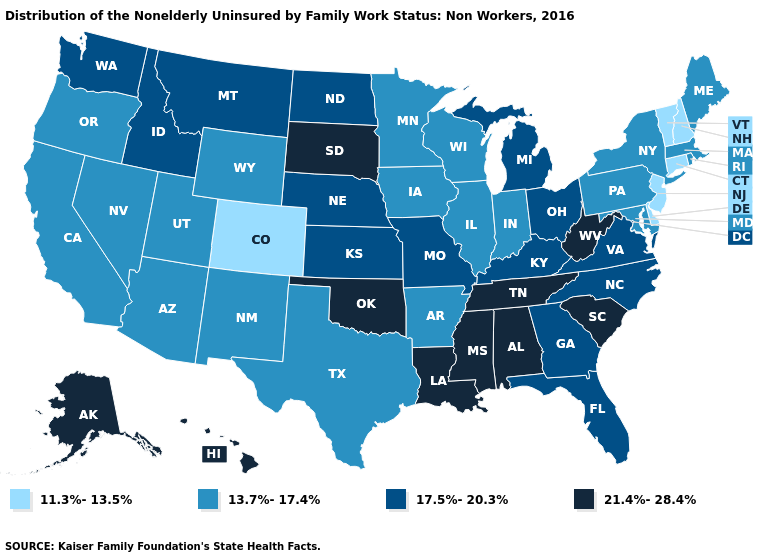What is the value of Maine?
Short answer required. 13.7%-17.4%. Name the states that have a value in the range 21.4%-28.4%?
Be succinct. Alabama, Alaska, Hawaii, Louisiana, Mississippi, Oklahoma, South Carolina, South Dakota, Tennessee, West Virginia. Name the states that have a value in the range 21.4%-28.4%?
Give a very brief answer. Alabama, Alaska, Hawaii, Louisiana, Mississippi, Oklahoma, South Carolina, South Dakota, Tennessee, West Virginia. Does Massachusetts have the same value as Utah?
Give a very brief answer. Yes. What is the value of Michigan?
Answer briefly. 17.5%-20.3%. Name the states that have a value in the range 11.3%-13.5%?
Short answer required. Colorado, Connecticut, Delaware, New Hampshire, New Jersey, Vermont. Does West Virginia have a lower value than Vermont?
Keep it brief. No. Does Mississippi have the lowest value in the USA?
Concise answer only. No. What is the value of Mississippi?
Write a very short answer. 21.4%-28.4%. What is the value of Pennsylvania?
Answer briefly. 13.7%-17.4%. Does Maine have the same value as Alaska?
Keep it brief. No. What is the value of Nevada?
Quick response, please. 13.7%-17.4%. What is the value of Florida?
Give a very brief answer. 17.5%-20.3%. What is the highest value in the MidWest ?
Quick response, please. 21.4%-28.4%. Name the states that have a value in the range 17.5%-20.3%?
Keep it brief. Florida, Georgia, Idaho, Kansas, Kentucky, Michigan, Missouri, Montana, Nebraska, North Carolina, North Dakota, Ohio, Virginia, Washington. 